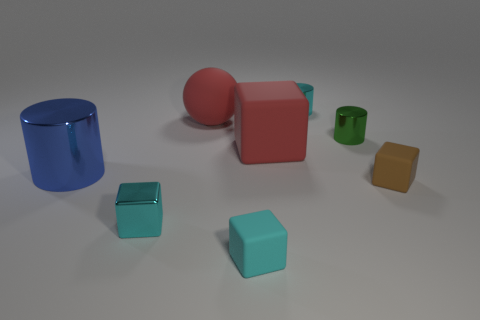Subtract all large cubes. How many cubes are left? 3 Subtract all blue cylinders. How many cyan blocks are left? 2 Subtract all brown blocks. How many blocks are left? 3 Subtract all red blocks. Subtract all purple cylinders. How many blocks are left? 3 Add 1 small green rubber objects. How many objects exist? 9 Subtract all cylinders. How many objects are left? 5 Add 5 matte blocks. How many matte blocks exist? 8 Subtract 1 cyan cylinders. How many objects are left? 7 Subtract all cyan cylinders. Subtract all brown matte things. How many objects are left? 6 Add 8 red rubber things. How many red rubber things are left? 10 